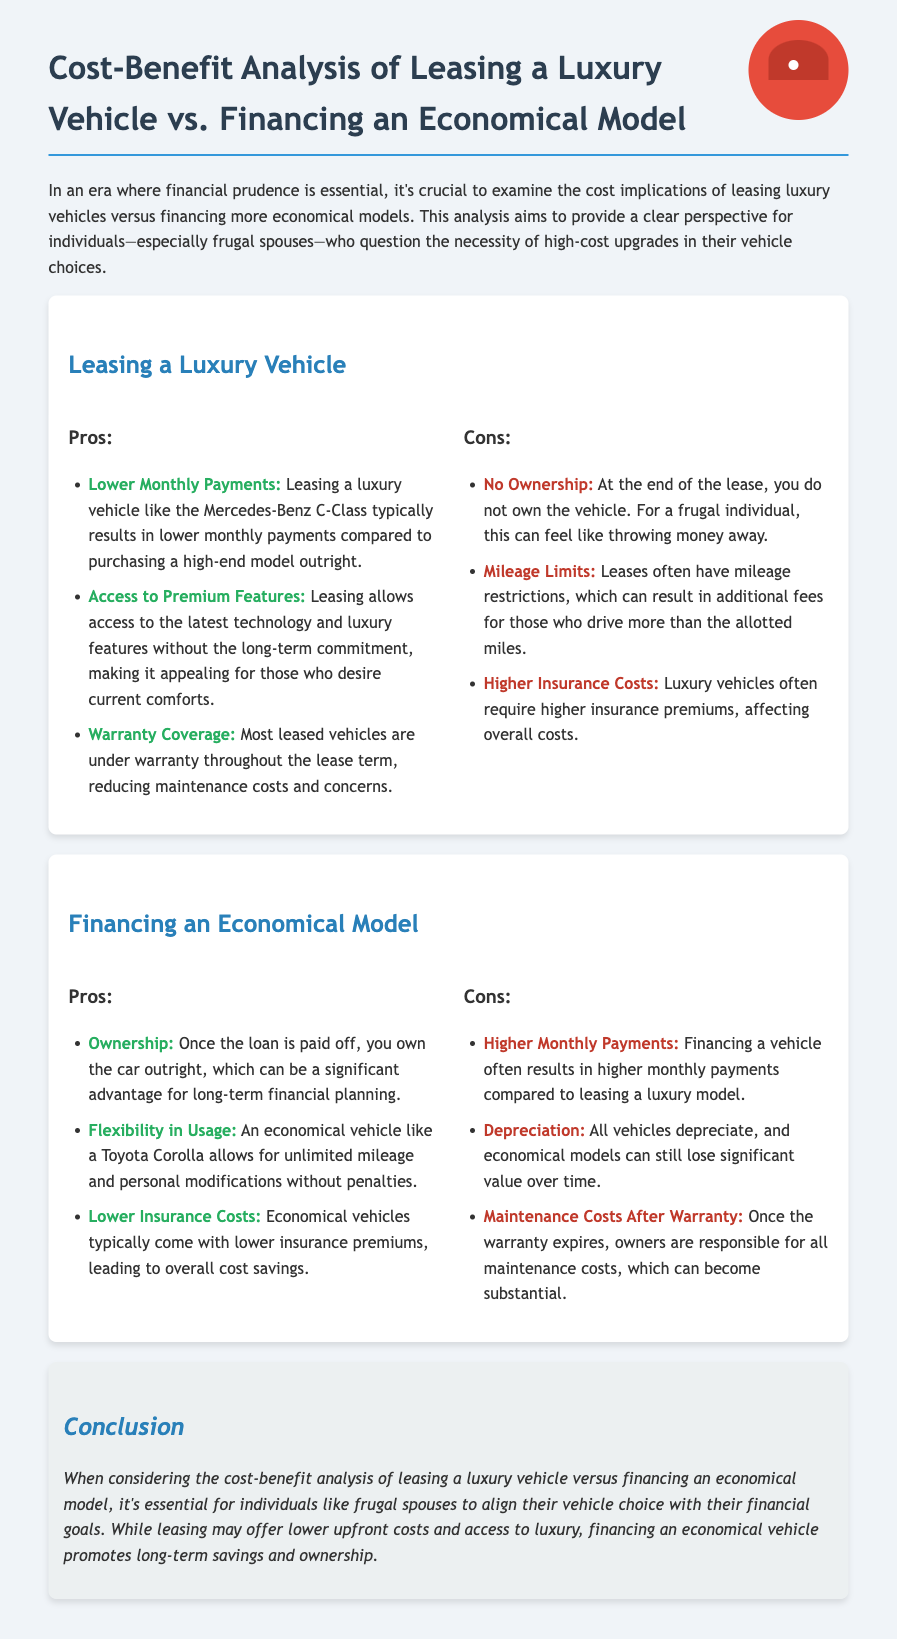What are the monthly payments like for leasing a luxury vehicle? Leasing a luxury vehicle typically results in lower monthly payments compared to purchasing a high-end model outright.
Answer: Lower What is a major downside of leasing a luxury vehicle? A significant negative aspect of leasing is that at the end of the lease, you do not own the vehicle.
Answer: No Ownership What are the potential financial effects of mileage limits in lease agreements? Mileage restrictions can result in additional fees for those who drive more than the allotted miles.
Answer: Additional fees What is a notable advantage of owning an economical vehicle? One major benefit is once the loan is paid off, you own the car outright.
Answer: Ownership How do insurance costs compare between luxury and economical vehicles? Luxury vehicles often require higher insurance premiums compared to economical vehicles.
Answer: Higher What is a critical consideration for a frugal spouse when choosing a vehicle? It is essential to align their vehicle choice with their financial goals.
Answer: Financial goals What happens to vehicles once their warranty expires? After the warranty expires, owners are responsible for all maintenance costs.
Answer: Maintenance costs What is typically required if financing an economical vehicle? Financing a vehicle often results in higher monthly payments compared to leasing a luxury model.
Answer: Higher monthly payments 